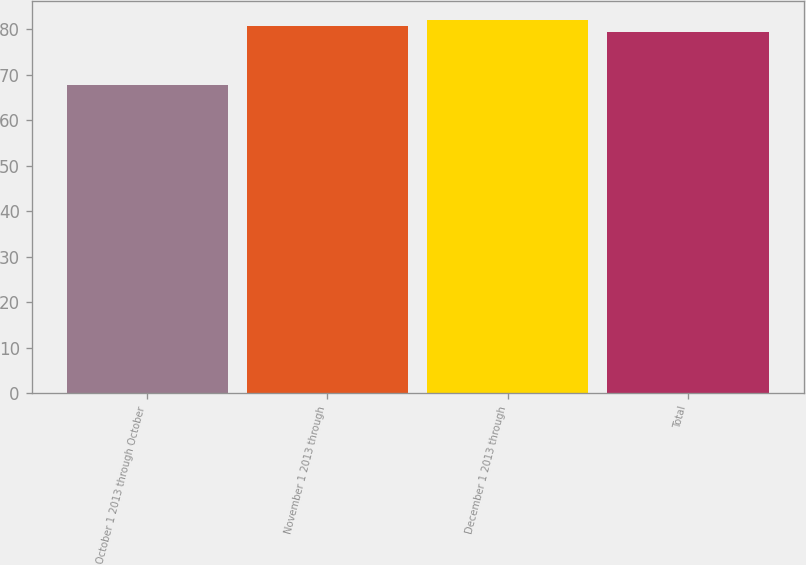<chart> <loc_0><loc_0><loc_500><loc_500><bar_chart><fcel>October 1 2013 through October<fcel>November 1 2013 through<fcel>December 1 2013 through<fcel>Total<nl><fcel>67.72<fcel>80.68<fcel>82.05<fcel>79.31<nl></chart> 